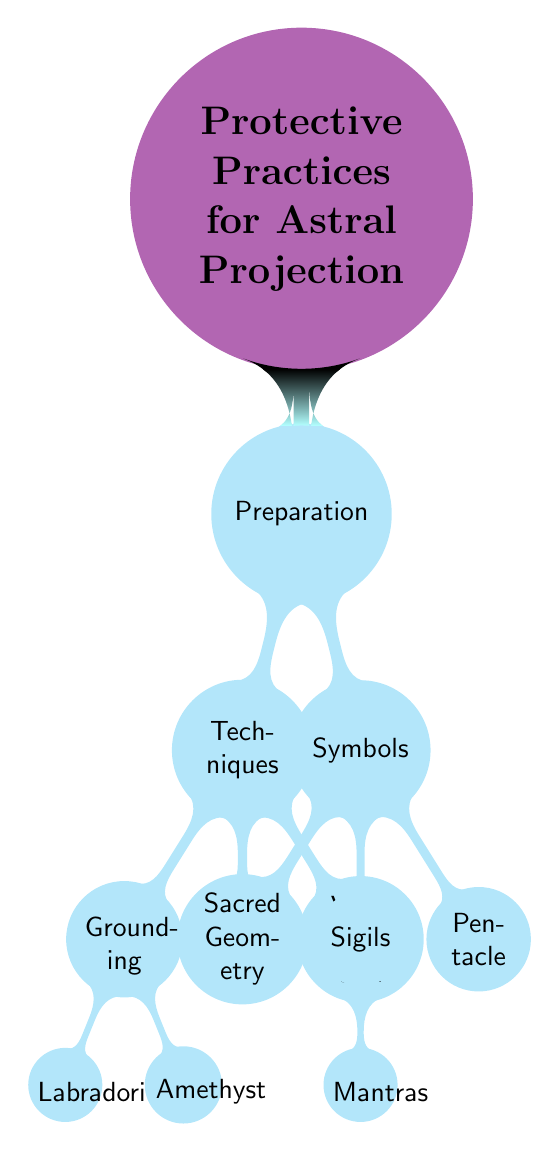What is the root concept of the diagram? The root concept is the central idea of the diagram, which can be found at the top level. In this case, it is "Protective Practices for Astral Projection," indicating the main topic being presented.
Answer: Protective Practices for Astral Projection How many child nodes does "Preparation" have? To determine the number of child nodes under "Preparation," you count each node connected directly beneath it. "Preparation" has two child nodes: "Techniques" and "Symbols."
Answer: 2 What are the two main categories under "Preparation"? The main categories can be identified by looking at the two child nodes stemming from "Preparation." They are "Techniques" and "Symbols."
Answer: Techniques, Symbols Which technique includes the stone "Amethyst"? By following the connections from the node "Techniques," we see that "Grounding" has two associated items, one of which is "Amethyst." It is listed as a specific type of grounding technique.
Answer: Grounding What is one of the symbols listed in the diagram? The symbols connected to the "Symbols" node can be identified easily; one of the symbols is "Sacred Geometry." This is among the three listed symbols in that category.
Answer: Sacred Geometry What is a technique that involves "Visualization"? The diagram shows that "Visualization" is a specific technique under the category of "Techniques." According to the flow, "Visualization" has a child node labeled "Mantras."
Answer: Visualization Name one protective stone associated with "Grounding." The node "Grounding" has two stones associated with it. Both "Labradorite" and "Amethyst" are protective stones listed under this technique.
Answer: Labradorite How many nodes are associated with "Techniques"? To find the number of nodes under "Techniques," you count both the direct techniques and any additional connections they may have. "Techniques" has three associated nodes: "Grounding," "Shielding," and "Visualization."
Answer: 3 What color represents the "root concept"? The root concept in the diagram is represented with a distinct color, which can easily be seen as "violet!60." This specifies the visual identification of the main topic.
Answer: Violet!60 